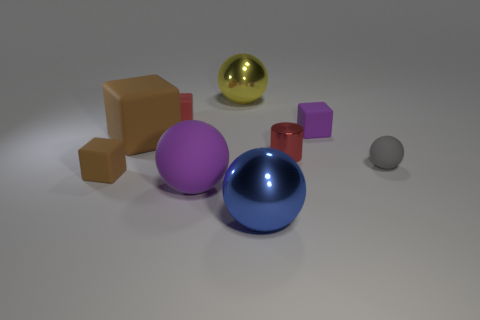Add 1 brown matte things. How many objects exist? 10 Subtract all cubes. How many objects are left? 5 Add 9 purple rubber blocks. How many purple rubber blocks are left? 10 Add 8 large purple shiny balls. How many large purple shiny balls exist? 8 Subtract 0 blue cylinders. How many objects are left? 9 Subtract all big purple rubber objects. Subtract all matte blocks. How many objects are left? 4 